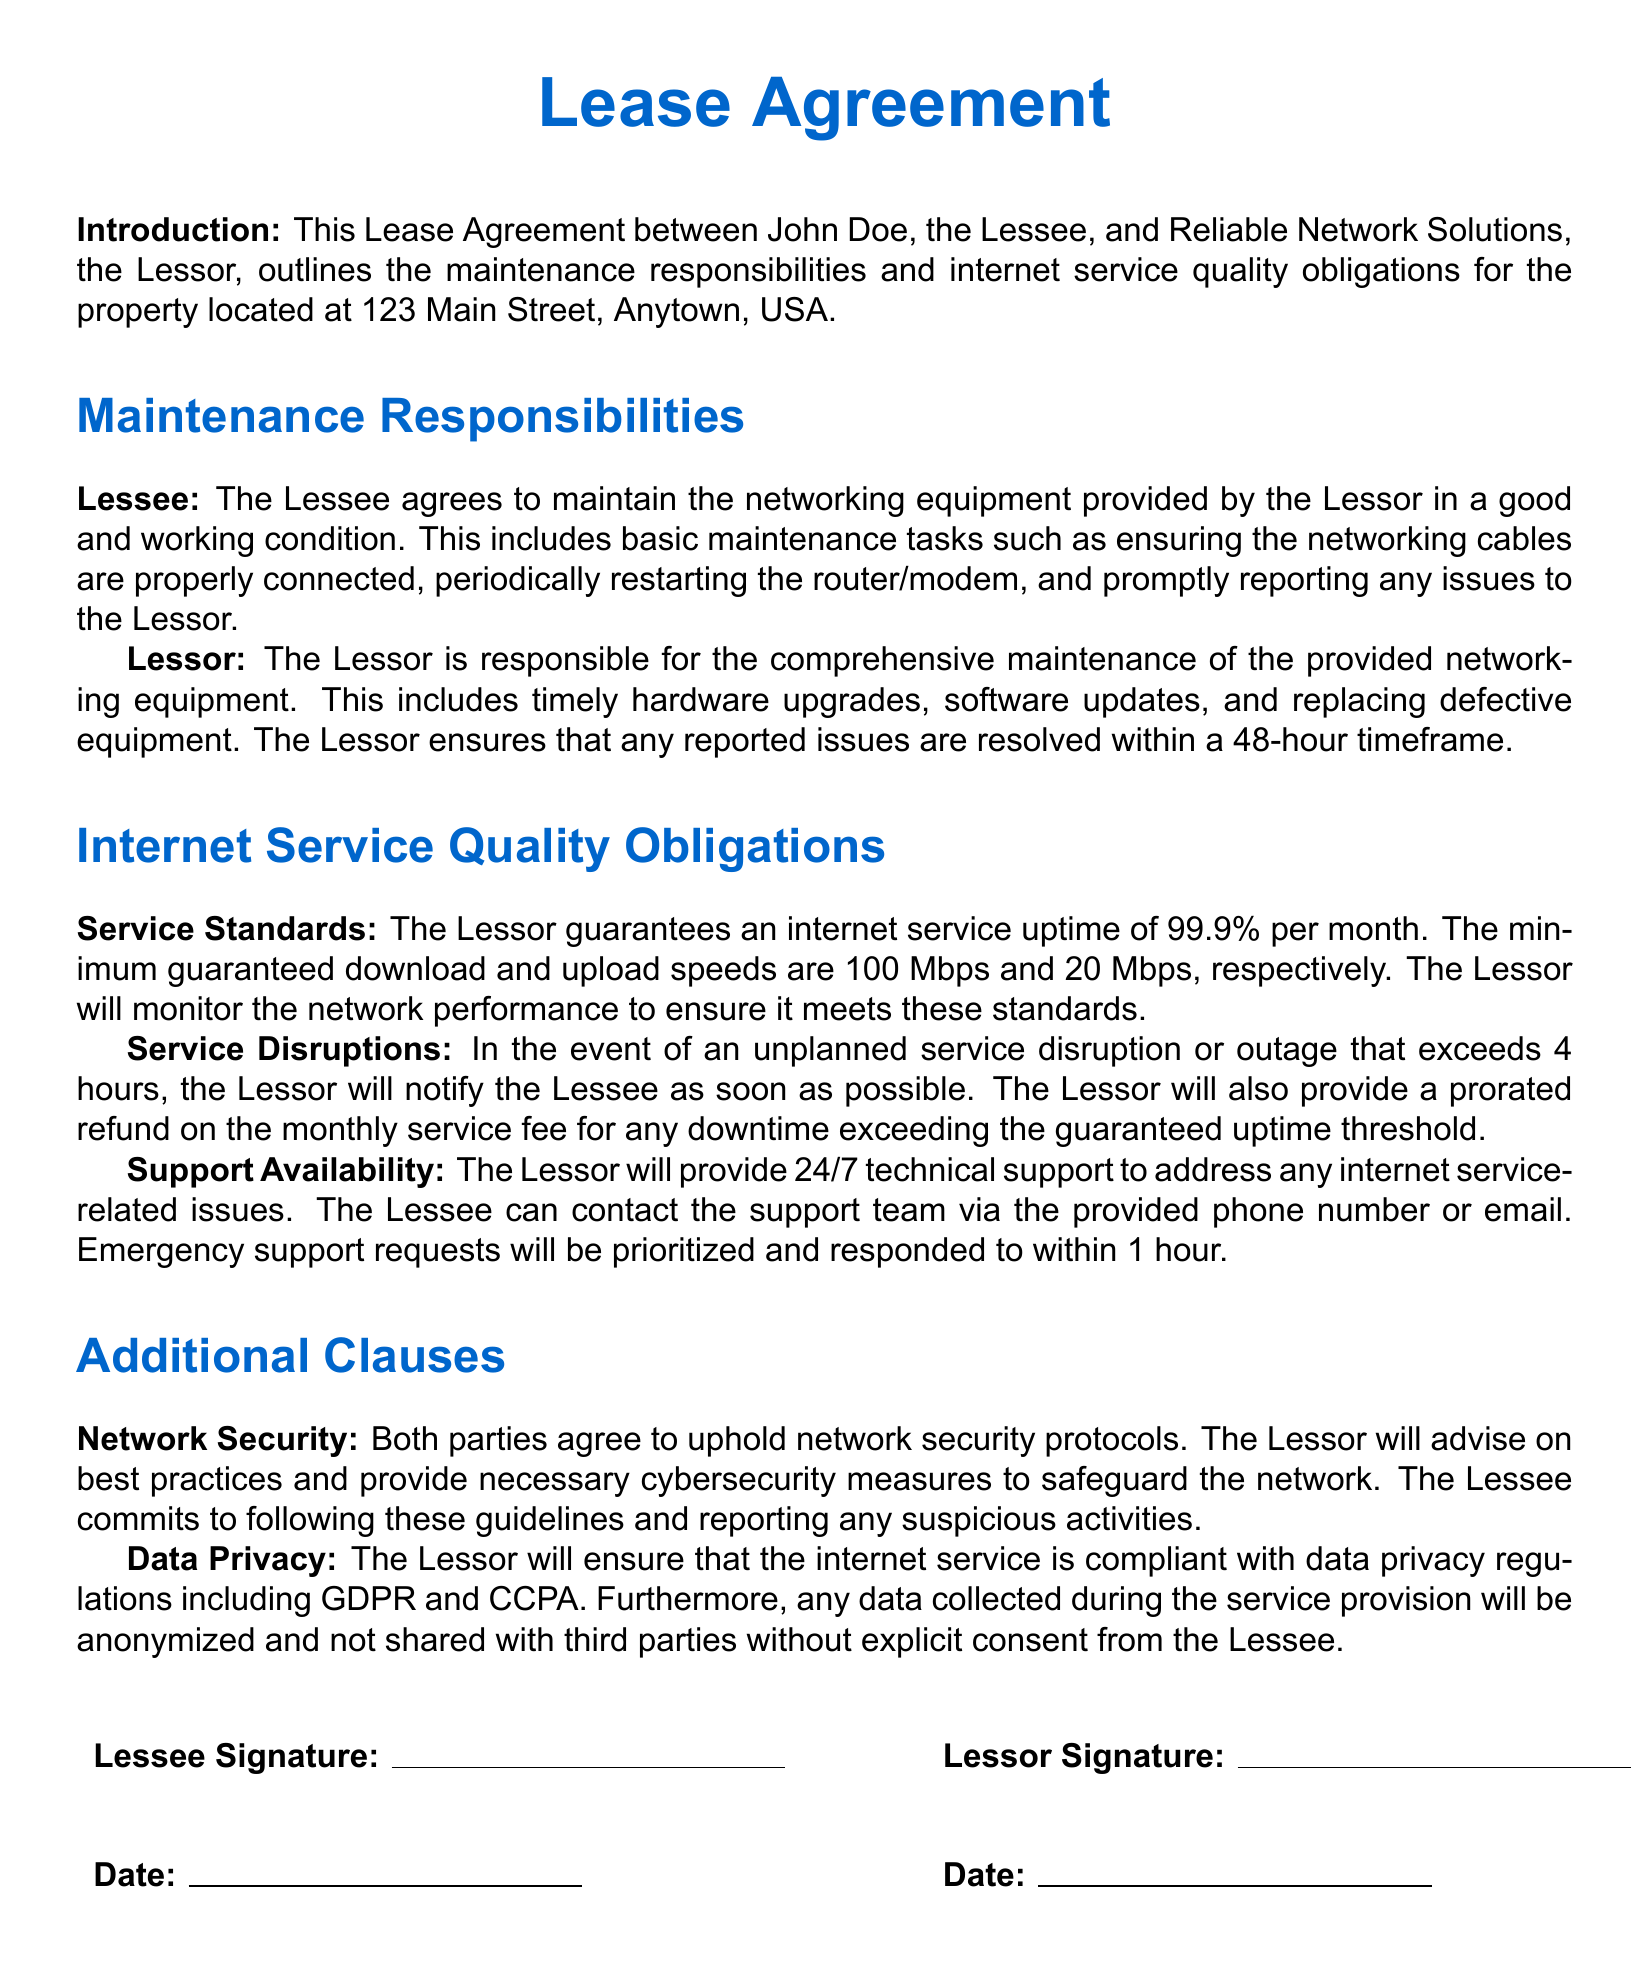What is the name of the Lessee? The document states the Lessee's name is John Doe.
Answer: John Doe What is the address of the property? The address is provided under the introduction of the document as the location of the property.
Answer: 123 Main Street, Anytown, USA What is the guaranteed internet service uptime? The document specifies the uptime guarantee in the Internet Service Quality Obligations section.
Answer: 99.9% What are the minimum guaranteed download speeds? The minimum download speed is explicitly mentioned in the document under Service Standards.
Answer: 100 Mbps What is the Lessee's responsibility regarding networking equipment? The document outlines maintenance tasks the Lessee is responsible for in the Maintenance Responsibilities section.
Answer: Maintain in good working condition What is the Lessor's response time for reported issues? The document specifies the timeframe within which the Lessor should resolve reported issues.
Answer: 48 hours How long does the Lessor have to notify the Lessee of service disruptions? The document discusses notification procedures regarding service disruptions in the Service Disruptions section.
Answer: As soon as possible What is the refund policy for downtime exceeding the guaranteed uptime? The policy concerning refunds for uptime issues is detailed in the Service Disruptions section of the document.
Answer: Prorated refund What type of support is available to the Lessee? The document states the type of support offered by the Lessor under Support Availability.
Answer: 24/7 technical support What regulations does the Lessor comply with regarding data privacy? The data privacy compliance is specified in the Additional Clauses section.
Answer: GDPR and CCPA 